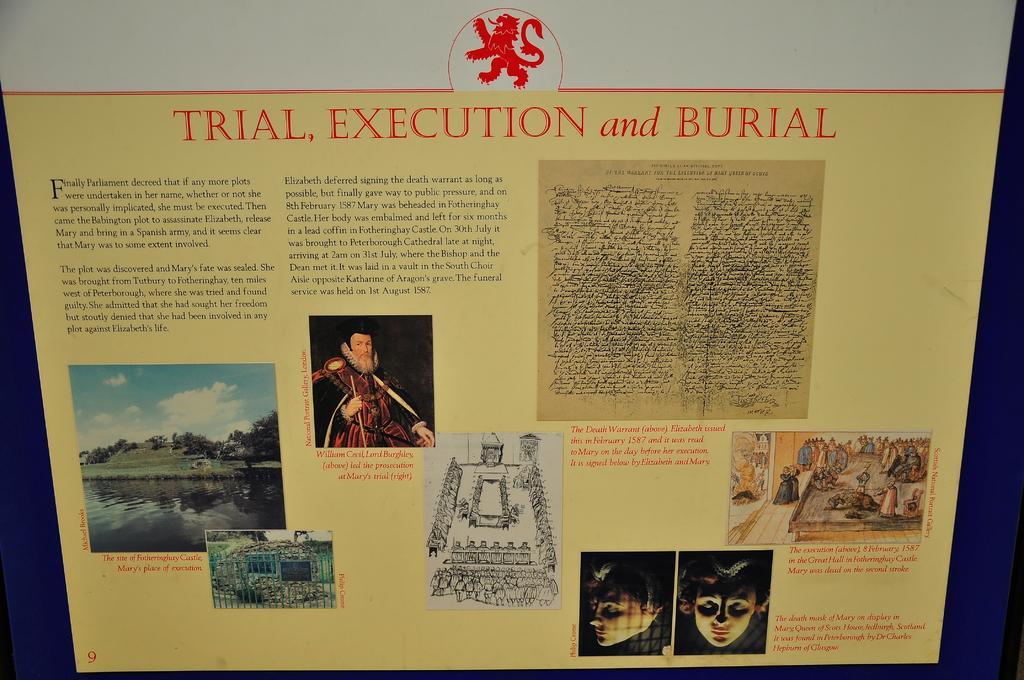What single digit number is seen on the very bottom left corner?
Keep it short and to the point. 9. What being shown in the pictures?
Provide a succinct answer. Trial, execution and burial. 